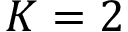Convert formula to latex. <formula><loc_0><loc_0><loc_500><loc_500>K = 2</formula> 